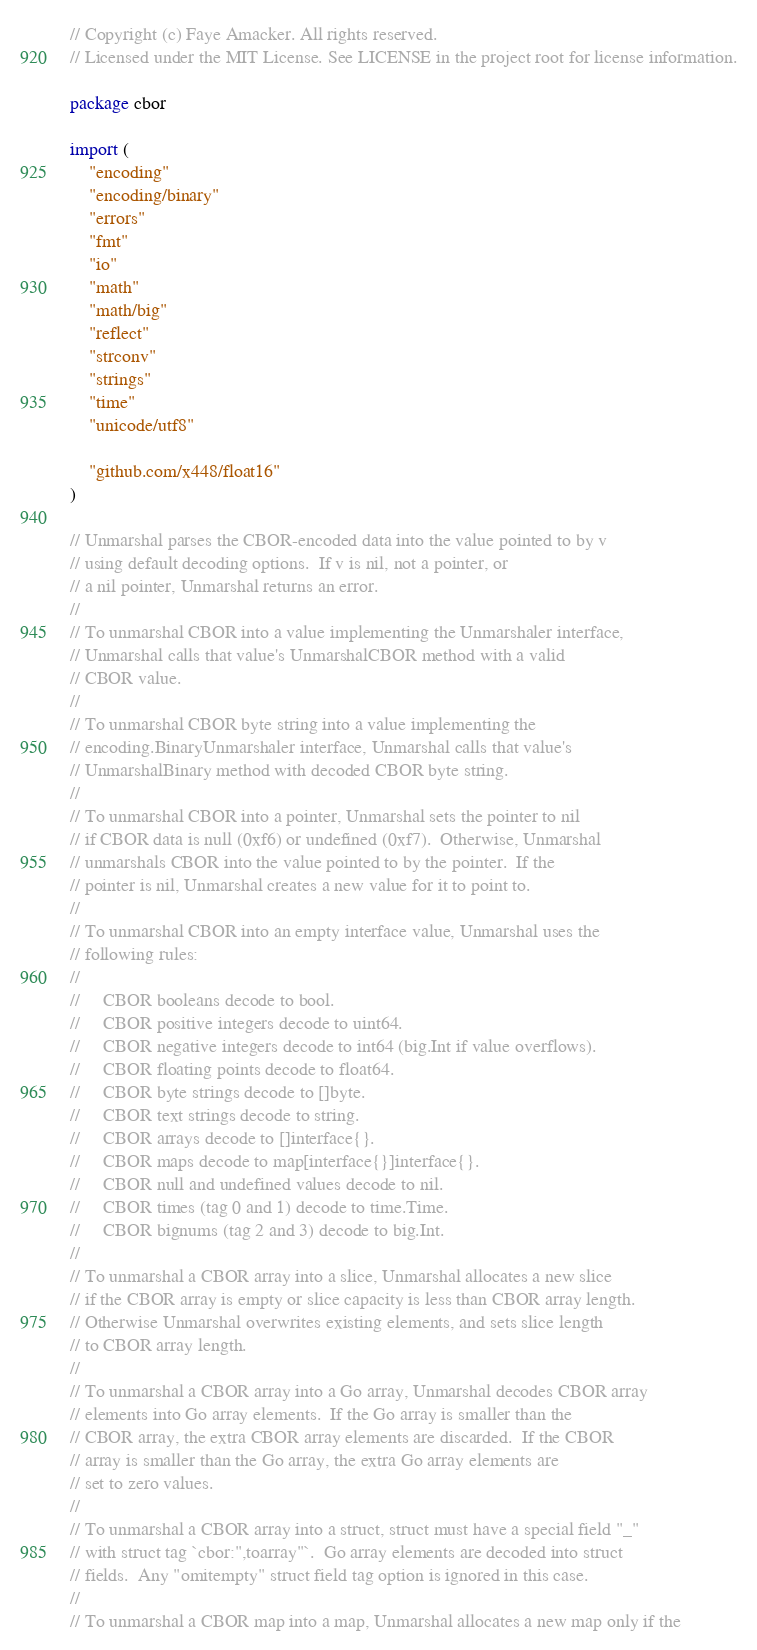Convert code to text. <code><loc_0><loc_0><loc_500><loc_500><_Go_>// Copyright (c) Faye Amacker. All rights reserved.
// Licensed under the MIT License. See LICENSE in the project root for license information.

package cbor

import (
	"encoding"
	"encoding/binary"
	"errors"
	"fmt"
	"io"
	"math"
	"math/big"
	"reflect"
	"strconv"
	"strings"
	"time"
	"unicode/utf8"

	"github.com/x448/float16"
)

// Unmarshal parses the CBOR-encoded data into the value pointed to by v
// using default decoding options.  If v is nil, not a pointer, or
// a nil pointer, Unmarshal returns an error.
//
// To unmarshal CBOR into a value implementing the Unmarshaler interface,
// Unmarshal calls that value's UnmarshalCBOR method with a valid
// CBOR value.
//
// To unmarshal CBOR byte string into a value implementing the
// encoding.BinaryUnmarshaler interface, Unmarshal calls that value's
// UnmarshalBinary method with decoded CBOR byte string.
//
// To unmarshal CBOR into a pointer, Unmarshal sets the pointer to nil
// if CBOR data is null (0xf6) or undefined (0xf7).  Otherwise, Unmarshal
// unmarshals CBOR into the value pointed to by the pointer.  If the
// pointer is nil, Unmarshal creates a new value for it to point to.
//
// To unmarshal CBOR into an empty interface value, Unmarshal uses the
// following rules:
//
//     CBOR booleans decode to bool.
//     CBOR positive integers decode to uint64.
//     CBOR negative integers decode to int64 (big.Int if value overflows).
//     CBOR floating points decode to float64.
//     CBOR byte strings decode to []byte.
//     CBOR text strings decode to string.
//     CBOR arrays decode to []interface{}.
//     CBOR maps decode to map[interface{}]interface{}.
//     CBOR null and undefined values decode to nil.
//     CBOR times (tag 0 and 1) decode to time.Time.
//     CBOR bignums (tag 2 and 3) decode to big.Int.
//
// To unmarshal a CBOR array into a slice, Unmarshal allocates a new slice
// if the CBOR array is empty or slice capacity is less than CBOR array length.
// Otherwise Unmarshal overwrites existing elements, and sets slice length
// to CBOR array length.
//
// To unmarshal a CBOR array into a Go array, Unmarshal decodes CBOR array
// elements into Go array elements.  If the Go array is smaller than the
// CBOR array, the extra CBOR array elements are discarded.  If the CBOR
// array is smaller than the Go array, the extra Go array elements are
// set to zero values.
//
// To unmarshal a CBOR array into a struct, struct must have a special field "_"
// with struct tag `cbor:",toarray"`.  Go array elements are decoded into struct
// fields.  Any "omitempty" struct field tag option is ignored in this case.
//
// To unmarshal a CBOR map into a map, Unmarshal allocates a new map only if the</code> 